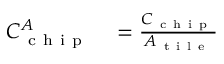<formula> <loc_0><loc_0><loc_500><loc_500>\begin{array} { r l } { C _ { c h i p } ^ { A } } & = \frac { C _ { c h i p } } { A _ { t i l e } } } \end{array}</formula> 